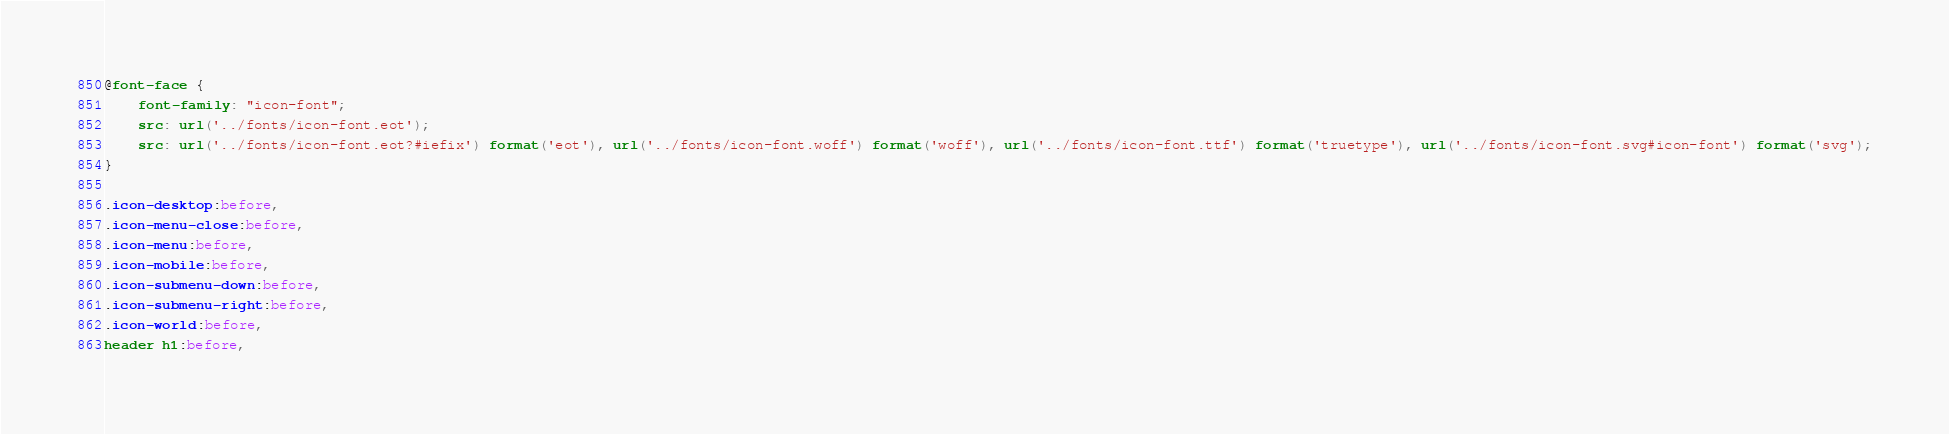Convert code to text. <code><loc_0><loc_0><loc_500><loc_500><_CSS_>@font-face {
	font-family: "icon-font";
	src: url('../fonts/icon-font.eot');
	src: url('../fonts/icon-font.eot?#iefix') format('eot'), url('../fonts/icon-font.woff') format('woff'), url('../fonts/icon-font.ttf') format('truetype'), url('../fonts/icon-font.svg#icon-font') format('svg');
}

.icon-desktop:before,
.icon-menu-close:before,
.icon-menu:before,
.icon-mobile:before,
.icon-submenu-down:before,
.icon-submenu-right:before,
.icon-world:before,
header h1:before,</code> 